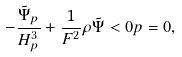Convert formula to latex. <formula><loc_0><loc_0><loc_500><loc_500>- \frac { \tilde { \Psi } _ { p } } { H ^ { 3 } _ { p } } + \frac { 1 } { F ^ { 2 } } \rho \tilde { \Psi } < 0 p = 0 ,</formula> 